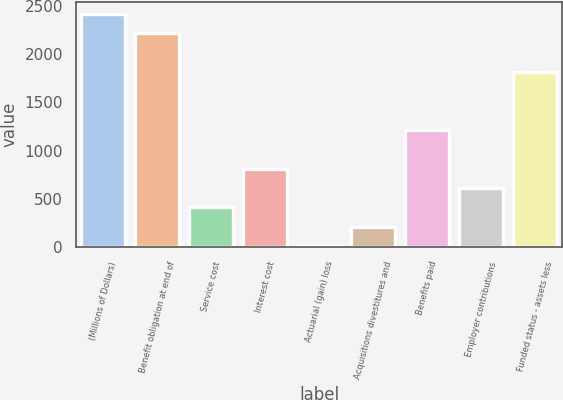<chart> <loc_0><loc_0><loc_500><loc_500><bar_chart><fcel>(Millions of Dollars)<fcel>Benefit obligation at end of<fcel>Service cost<fcel>Interest cost<fcel>Actuarial (gain) loss<fcel>Acquisitions divestitures and<fcel>Benefits paid<fcel>Employer contributions<fcel>Funded status - assets less<nl><fcel>2418.12<fcel>2217.56<fcel>412.52<fcel>813.64<fcel>11.4<fcel>211.96<fcel>1214.76<fcel>613.08<fcel>1816.44<nl></chart> 